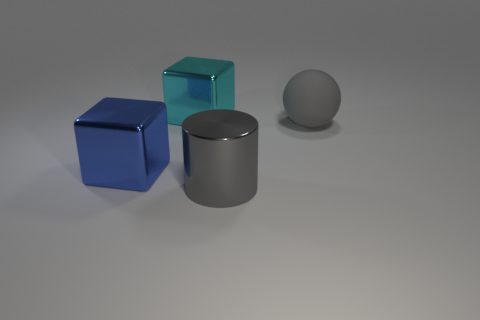Subtract all cyan cubes. How many cubes are left? 1 Add 3 big metal things. How many objects exist? 7 Subtract all cylinders. How many objects are left? 3 Subtract 1 blocks. How many blocks are left? 1 Subtract all cyan cylinders. Subtract all brown balls. How many cylinders are left? 1 Subtract all large yellow matte cylinders. Subtract all large cyan objects. How many objects are left? 3 Add 3 big gray rubber objects. How many big gray rubber objects are left? 4 Add 4 gray metallic cylinders. How many gray metallic cylinders exist? 5 Subtract 1 cyan cubes. How many objects are left? 3 